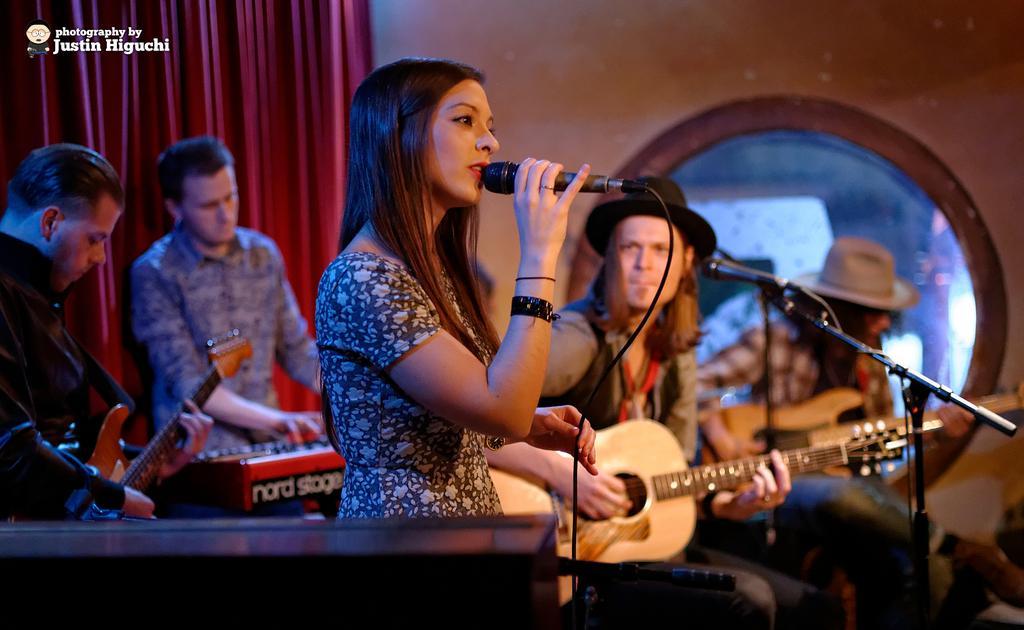Describe this image in one or two sentences. There are group of people, one woman is holding a mic and singing a song this man is playing guitar and is looking at this woman. In the background a man is playing a piano and left side the man is holding a guitar and playing a guitar. In the background there is a red colour curtain. 